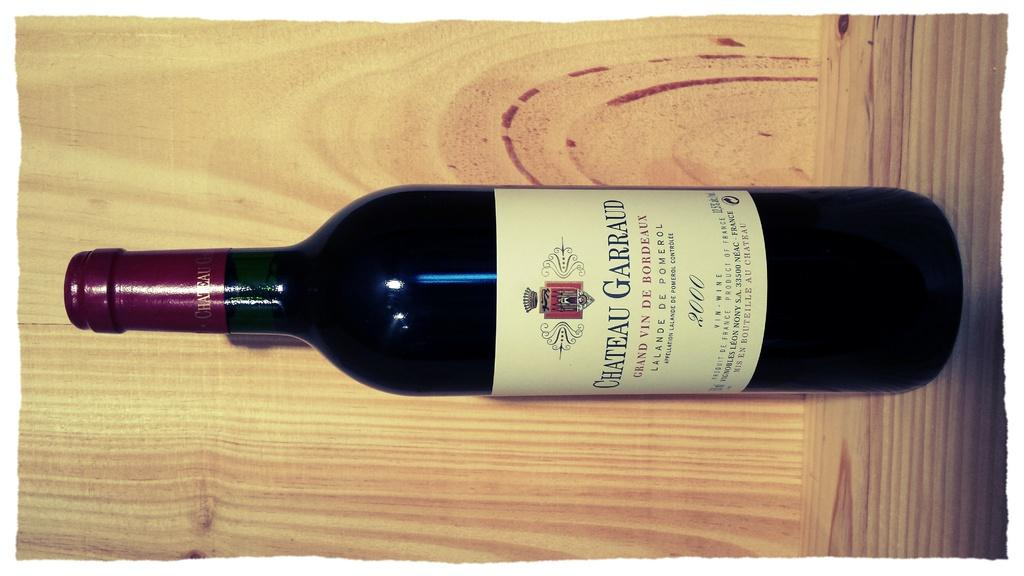Provide a one-sentence caption for the provided image. A bottle of Chateau Garraud is on a wooden shelf. 